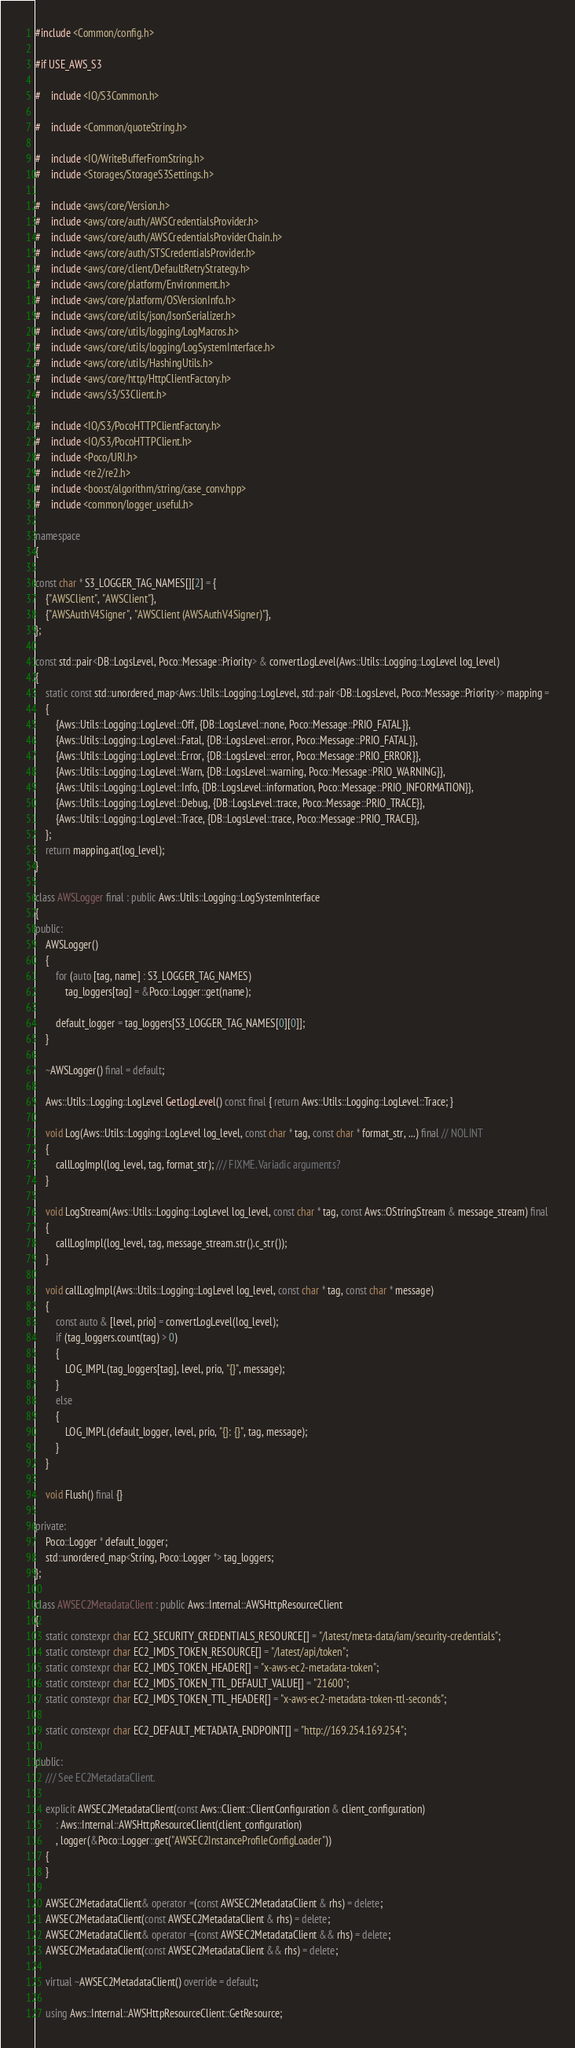Convert code to text. <code><loc_0><loc_0><loc_500><loc_500><_C++_>#include <Common/config.h>

#if USE_AWS_S3

#    include <IO/S3Common.h>

#    include <Common/quoteString.h>

#    include <IO/WriteBufferFromString.h>
#    include <Storages/StorageS3Settings.h>

#    include <aws/core/Version.h>
#    include <aws/core/auth/AWSCredentialsProvider.h>
#    include <aws/core/auth/AWSCredentialsProviderChain.h>
#    include <aws/core/auth/STSCredentialsProvider.h>
#    include <aws/core/client/DefaultRetryStrategy.h>
#    include <aws/core/platform/Environment.h>
#    include <aws/core/platform/OSVersionInfo.h>
#    include <aws/core/utils/json/JsonSerializer.h>
#    include <aws/core/utils/logging/LogMacros.h>
#    include <aws/core/utils/logging/LogSystemInterface.h>
#    include <aws/core/utils/HashingUtils.h>
#    include <aws/core/http/HttpClientFactory.h>
#    include <aws/s3/S3Client.h>

#    include <IO/S3/PocoHTTPClientFactory.h>
#    include <IO/S3/PocoHTTPClient.h>
#    include <Poco/URI.h>
#    include <re2/re2.h>
#    include <boost/algorithm/string/case_conv.hpp>
#    include <common/logger_useful.h>

namespace
{

const char * S3_LOGGER_TAG_NAMES[][2] = {
    {"AWSClient", "AWSClient"},
    {"AWSAuthV4Signer", "AWSClient (AWSAuthV4Signer)"},
};

const std::pair<DB::LogsLevel, Poco::Message::Priority> & convertLogLevel(Aws::Utils::Logging::LogLevel log_level)
{
    static const std::unordered_map<Aws::Utils::Logging::LogLevel, std::pair<DB::LogsLevel, Poco::Message::Priority>> mapping =
    {
        {Aws::Utils::Logging::LogLevel::Off, {DB::LogsLevel::none, Poco::Message::PRIO_FATAL}},
        {Aws::Utils::Logging::LogLevel::Fatal, {DB::LogsLevel::error, Poco::Message::PRIO_FATAL}},
        {Aws::Utils::Logging::LogLevel::Error, {DB::LogsLevel::error, Poco::Message::PRIO_ERROR}},
        {Aws::Utils::Logging::LogLevel::Warn, {DB::LogsLevel::warning, Poco::Message::PRIO_WARNING}},
        {Aws::Utils::Logging::LogLevel::Info, {DB::LogsLevel::information, Poco::Message::PRIO_INFORMATION}},
        {Aws::Utils::Logging::LogLevel::Debug, {DB::LogsLevel::trace, Poco::Message::PRIO_TRACE}},
        {Aws::Utils::Logging::LogLevel::Trace, {DB::LogsLevel::trace, Poco::Message::PRIO_TRACE}},
    };
    return mapping.at(log_level);
}

class AWSLogger final : public Aws::Utils::Logging::LogSystemInterface
{
public:
    AWSLogger()
    {
        for (auto [tag, name] : S3_LOGGER_TAG_NAMES)
            tag_loggers[tag] = &Poco::Logger::get(name);

        default_logger = tag_loggers[S3_LOGGER_TAG_NAMES[0][0]];
    }

    ~AWSLogger() final = default;

    Aws::Utils::Logging::LogLevel GetLogLevel() const final { return Aws::Utils::Logging::LogLevel::Trace; }

    void Log(Aws::Utils::Logging::LogLevel log_level, const char * tag, const char * format_str, ...) final // NOLINT
    {
        callLogImpl(log_level, tag, format_str); /// FIXME. Variadic arguments?
    }

    void LogStream(Aws::Utils::Logging::LogLevel log_level, const char * tag, const Aws::OStringStream & message_stream) final
    {
        callLogImpl(log_level, tag, message_stream.str().c_str());
    }

    void callLogImpl(Aws::Utils::Logging::LogLevel log_level, const char * tag, const char * message)
    {
        const auto & [level, prio] = convertLogLevel(log_level);
        if (tag_loggers.count(tag) > 0)
        {
            LOG_IMPL(tag_loggers[tag], level, prio, "{}", message);
        }
        else
        {
            LOG_IMPL(default_logger, level, prio, "{}: {}", tag, message);
        }
    }

    void Flush() final {}

private:
    Poco::Logger * default_logger;
    std::unordered_map<String, Poco::Logger *> tag_loggers;
};

class AWSEC2MetadataClient : public Aws::Internal::AWSHttpResourceClient
{
    static constexpr char EC2_SECURITY_CREDENTIALS_RESOURCE[] = "/latest/meta-data/iam/security-credentials";
    static constexpr char EC2_IMDS_TOKEN_RESOURCE[] = "/latest/api/token";
    static constexpr char EC2_IMDS_TOKEN_HEADER[] = "x-aws-ec2-metadata-token";
    static constexpr char EC2_IMDS_TOKEN_TTL_DEFAULT_VALUE[] = "21600";
    static constexpr char EC2_IMDS_TOKEN_TTL_HEADER[] = "x-aws-ec2-metadata-token-ttl-seconds";

    static constexpr char EC2_DEFAULT_METADATA_ENDPOINT[] = "http://169.254.169.254";

public:
    /// See EC2MetadataClient.

    explicit AWSEC2MetadataClient(const Aws::Client::ClientConfiguration & client_configuration)
        : Aws::Internal::AWSHttpResourceClient(client_configuration)
        , logger(&Poco::Logger::get("AWSEC2InstanceProfileConfigLoader"))
    {
    }

    AWSEC2MetadataClient& operator =(const AWSEC2MetadataClient & rhs) = delete;
    AWSEC2MetadataClient(const AWSEC2MetadataClient & rhs) = delete;
    AWSEC2MetadataClient& operator =(const AWSEC2MetadataClient && rhs) = delete;
    AWSEC2MetadataClient(const AWSEC2MetadataClient && rhs) = delete;

    virtual ~AWSEC2MetadataClient() override = default;

    using Aws::Internal::AWSHttpResourceClient::GetResource;
</code> 